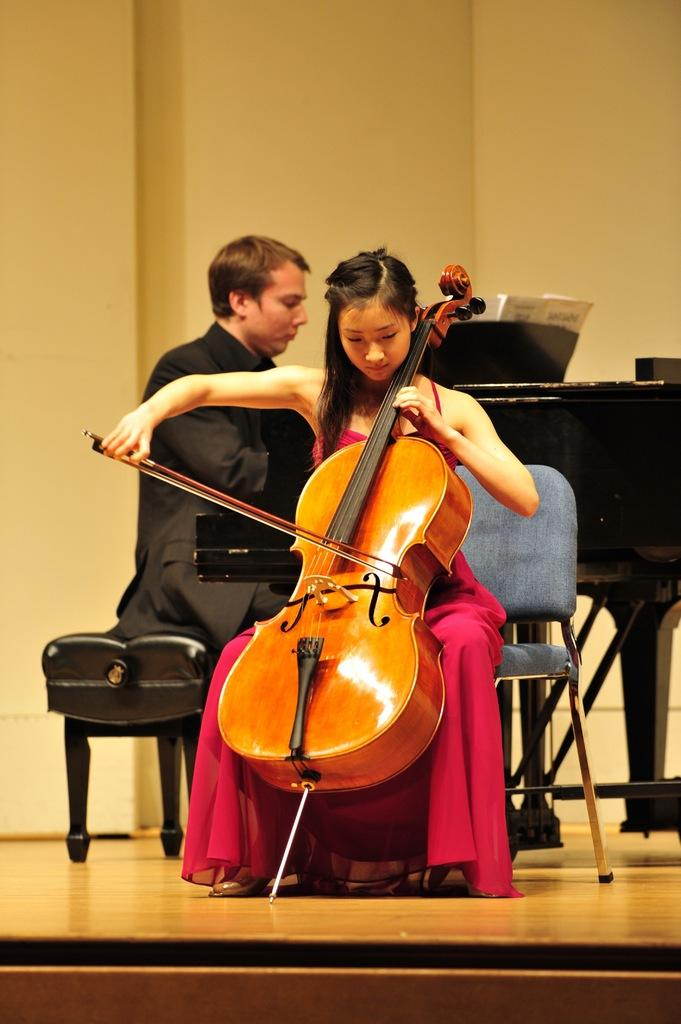What is the woman doing in the image? The woman is sitting on a chair and playing a violin. What is the man doing in the image? The man is sitting on a chair and playing a piano keyboard. What is the woman wearing in the image? The woman is wearing a red dress. What is the man wearing in the image? The man is wearing a black suit. What type of airplane is visible in the image? There is no airplane present in the image. What type of office equipment can be seen in the image? The image does not depict an office setting, and therefore no office equipment is visible. 